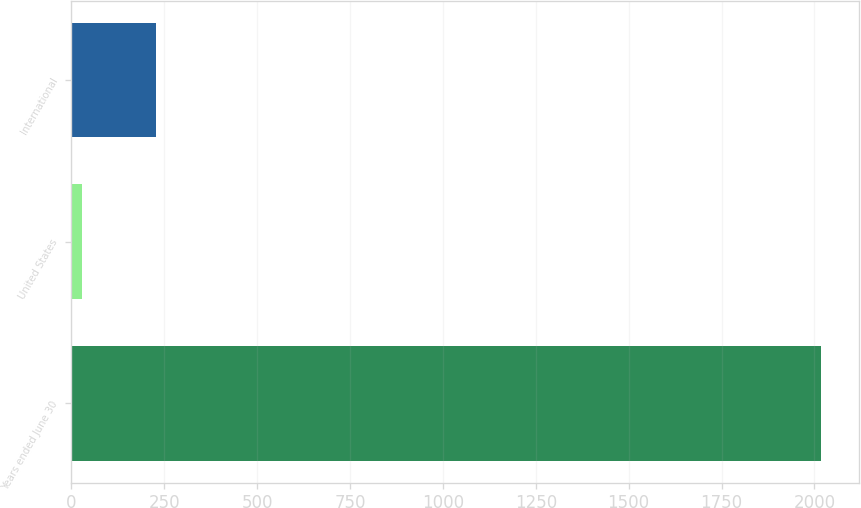Convert chart to OTSL. <chart><loc_0><loc_0><loc_500><loc_500><bar_chart><fcel>Years ended June 30<fcel>United States<fcel>International<nl><fcel>2019<fcel>28.6<fcel>227.64<nl></chart> 